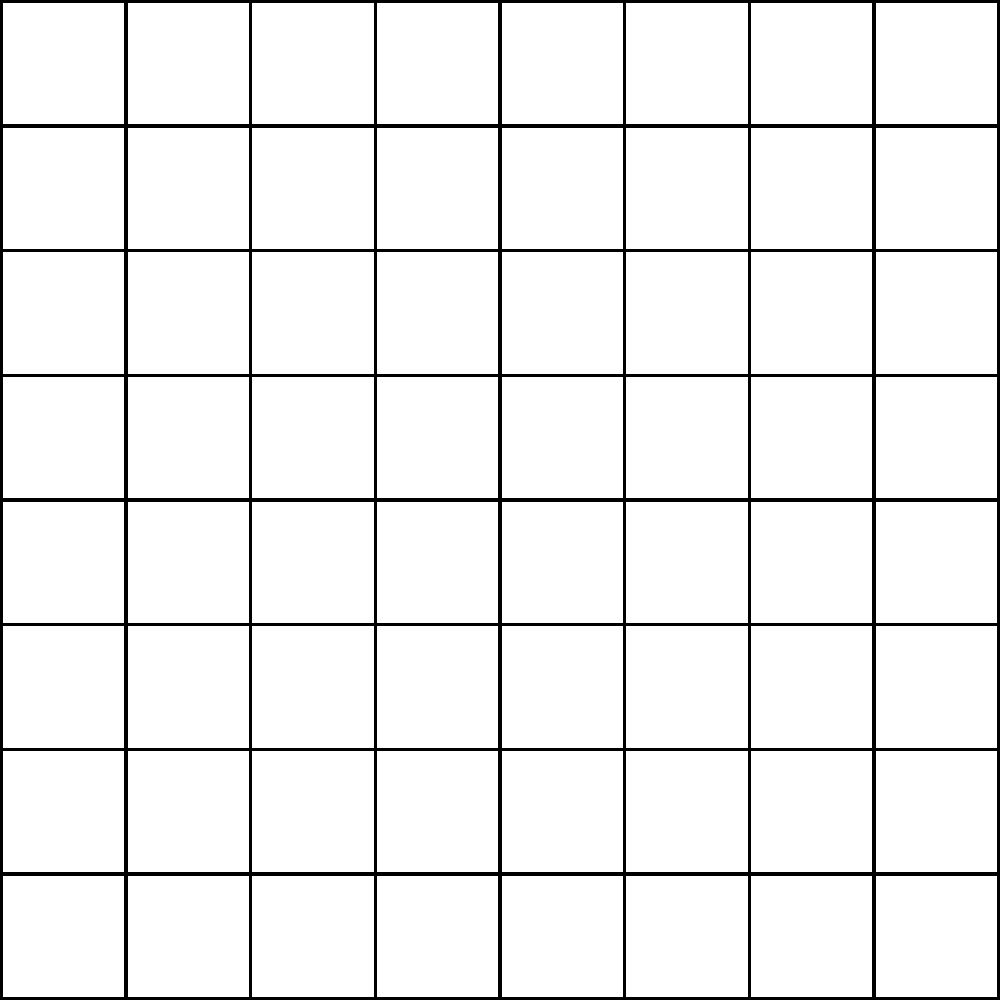In this Go board position, how many different groups of stones are present? To determine the number of groups in this Go board position, we need to follow these steps:

1. Identify the stones on the board:
   - There are four stones placed on the board.

2. Understand the concept of a group in Go:
   - A group consists of one or more stones of the same color that are connected horizontally or vertically.
   - Stones of the same color that are only connected diagonally are considered separate groups.

3. Analyze the position of each stone:
   - Black stone at the lower left (2,2)
   - White stone at the upper left (2,6)
   - White stone at the lower right (6,2)
   - Black stone at the upper right (6,6)

4. Count the groups:
   - The two black stones are not connected, so they form two separate groups.
   - The two white stones are not connected, so they also form two separate groups.

5. Sum up the total number of groups:
   - 2 black groups + 2 white groups = 4 total groups

Therefore, there are 4 different groups of stones present on this Go board.
Answer: 4 